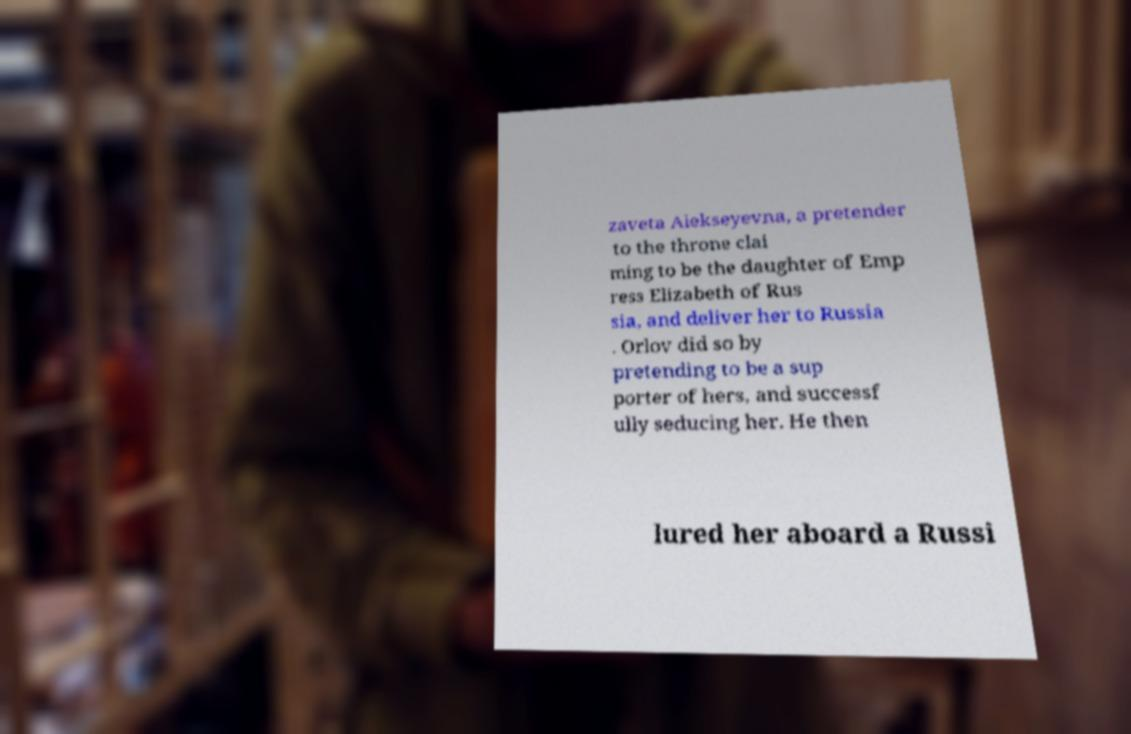What messages or text are displayed in this image? I need them in a readable, typed format. zaveta Alekseyevna, a pretender to the throne clai ming to be the daughter of Emp ress Elizabeth of Rus sia, and deliver her to Russia . Orlov did so by pretending to be a sup porter of hers, and successf ully seducing her. He then lured her aboard a Russi 